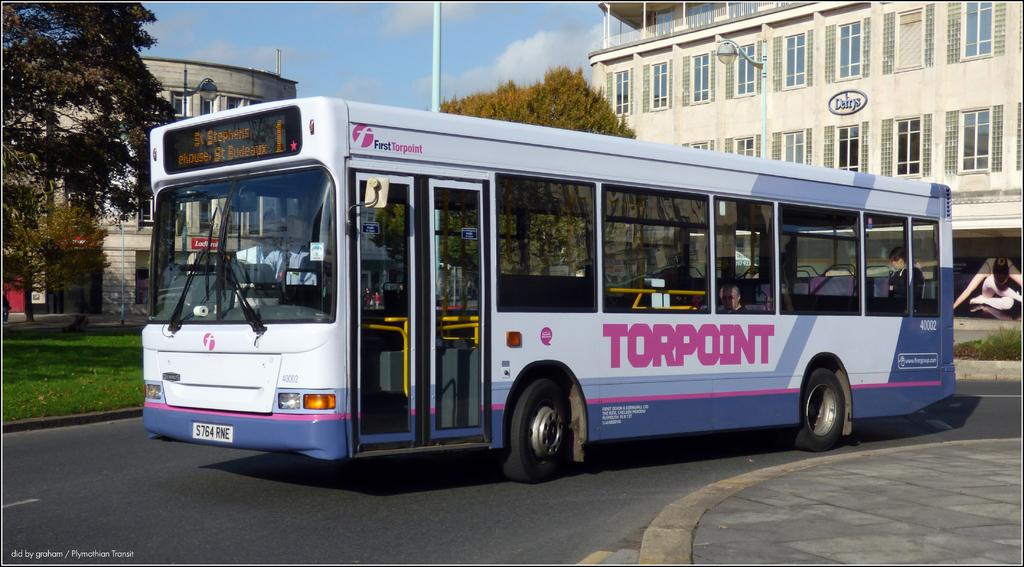<image>
Share a concise interpretation of the image provided. a Torpoint bus number 1 for St Stephens 